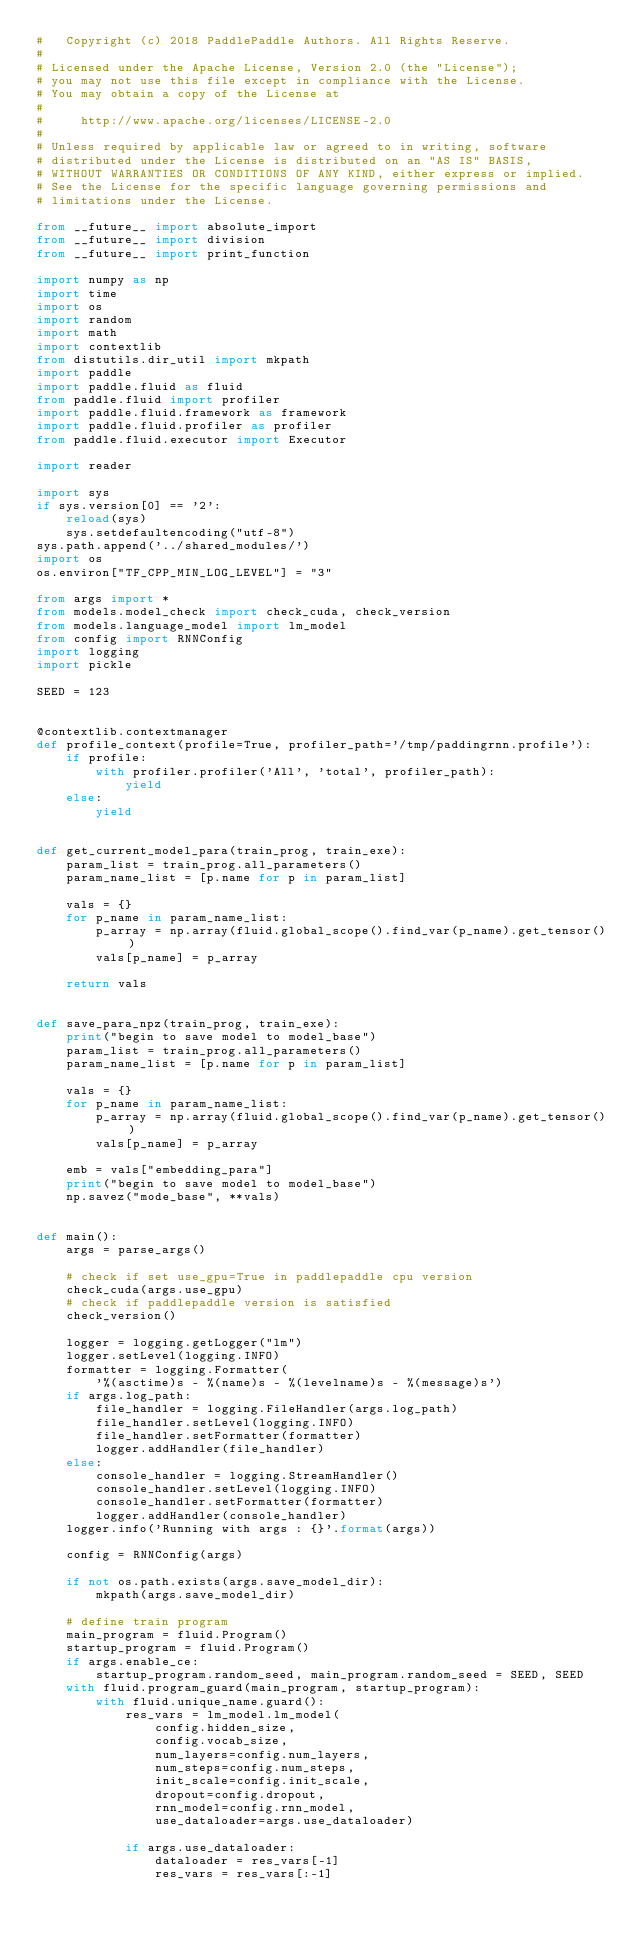Convert code to text. <code><loc_0><loc_0><loc_500><loc_500><_Python_>#   Copyright (c) 2018 PaddlePaddle Authors. All Rights Reserve.
#
# Licensed under the Apache License, Version 2.0 (the "License");
# you may not use this file except in compliance with the License.
# You may obtain a copy of the License at
#
#     http://www.apache.org/licenses/LICENSE-2.0
#
# Unless required by applicable law or agreed to in writing, software
# distributed under the License is distributed on an "AS IS" BASIS,
# WITHOUT WARRANTIES OR CONDITIONS OF ANY KIND, either express or implied.
# See the License for the specific language governing permissions and
# limitations under the License.

from __future__ import absolute_import
from __future__ import division
from __future__ import print_function

import numpy as np
import time
import os
import random
import math
import contextlib
from distutils.dir_util import mkpath
import paddle
import paddle.fluid as fluid
from paddle.fluid import profiler
import paddle.fluid.framework as framework
import paddle.fluid.profiler as profiler
from paddle.fluid.executor import Executor

import reader

import sys
if sys.version[0] == '2':
    reload(sys)
    sys.setdefaultencoding("utf-8")
sys.path.append('../shared_modules/')
import os
os.environ["TF_CPP_MIN_LOG_LEVEL"] = "3"

from args import *
from models.model_check import check_cuda, check_version
from models.language_model import lm_model
from config import RNNConfig
import logging
import pickle

SEED = 123


@contextlib.contextmanager
def profile_context(profile=True, profiler_path='/tmp/paddingrnn.profile'):
    if profile:
        with profiler.profiler('All', 'total', profiler_path):
            yield
    else:
        yield


def get_current_model_para(train_prog, train_exe):
    param_list = train_prog.all_parameters()
    param_name_list = [p.name for p in param_list]

    vals = {}
    for p_name in param_name_list:
        p_array = np.array(fluid.global_scope().find_var(p_name).get_tensor())
        vals[p_name] = p_array

    return vals


def save_para_npz(train_prog, train_exe):
    print("begin to save model to model_base")
    param_list = train_prog.all_parameters()
    param_name_list = [p.name for p in param_list]

    vals = {}
    for p_name in param_name_list:
        p_array = np.array(fluid.global_scope().find_var(p_name).get_tensor())
        vals[p_name] = p_array

    emb = vals["embedding_para"]
    print("begin to save model to model_base")
    np.savez("mode_base", **vals)


def main():
    args = parse_args()

    # check if set use_gpu=True in paddlepaddle cpu version
    check_cuda(args.use_gpu)
    # check if paddlepaddle version is satisfied
    check_version()

    logger = logging.getLogger("lm")
    logger.setLevel(logging.INFO)
    formatter = logging.Formatter(
        '%(asctime)s - %(name)s - %(levelname)s - %(message)s')
    if args.log_path:
        file_handler = logging.FileHandler(args.log_path)
        file_handler.setLevel(logging.INFO)
        file_handler.setFormatter(formatter)
        logger.addHandler(file_handler)
    else:
        console_handler = logging.StreamHandler()
        console_handler.setLevel(logging.INFO)
        console_handler.setFormatter(formatter)
        logger.addHandler(console_handler)
    logger.info('Running with args : {}'.format(args))

    config = RNNConfig(args)

    if not os.path.exists(args.save_model_dir):
        mkpath(args.save_model_dir)

    # define train program
    main_program = fluid.Program()
    startup_program = fluid.Program()
    if args.enable_ce:
        startup_program.random_seed, main_program.random_seed = SEED, SEED
    with fluid.program_guard(main_program, startup_program):
        with fluid.unique_name.guard():
            res_vars = lm_model.lm_model(
                config.hidden_size,
                config.vocab_size,
                num_layers=config.num_layers,
                num_steps=config.num_steps,
                init_scale=config.init_scale,
                dropout=config.dropout,
                rnn_model=config.rnn_model,
                use_dataloader=args.use_dataloader)

            if args.use_dataloader:
                dataloader = res_vars[-1]
                res_vars = res_vars[:-1]</code> 